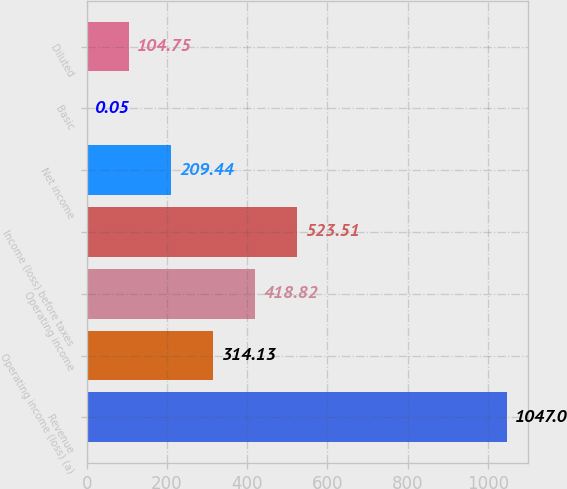Convert chart. <chart><loc_0><loc_0><loc_500><loc_500><bar_chart><fcel>Revenue<fcel>Operating income (loss) (a)<fcel>Operating income<fcel>Income (loss) before taxes<fcel>Net income<fcel>Basic<fcel>Diluted<nl><fcel>1047<fcel>314.13<fcel>418.82<fcel>523.51<fcel>209.44<fcel>0.05<fcel>104.75<nl></chart> 